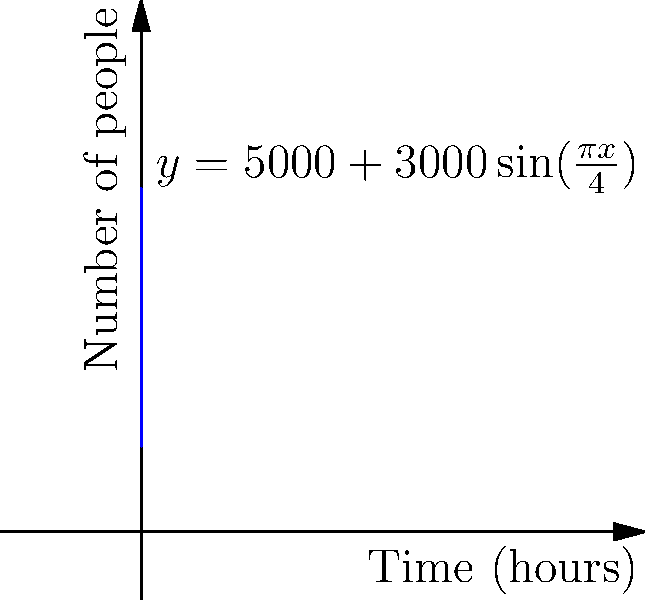As a hip-hop artist planning your debut concert, you want to understand crowd dynamics. The graph shows the number of people at a concert over time, represented by the function $y=5000+3000\sin(\frac{\pi x}{4})$, where $x$ is time in hours and $y$ is the number of people. Calculate the total person-hours spent at the concert during the 8-hour event. (Hint: Use a definite integral to find the area under the curve.) To solve this problem, we need to follow these steps:

1) The total person-hours is represented by the area under the curve from $x=0$ to $x=8$.

2) We can find this area using a definite integral:

   $$\int_0^8 [5000+3000\sin(\frac{\pi x}{4})] dx$$

3) Let's break this into two parts:
   
   $$\int_0^8 5000 dx + \int_0^8 3000\sin(\frac{\pi x}{4}) dx$$

4) For the first part:
   
   $$5000x|_0^8 = 5000(8) - 5000(0) = 40000$$

5) For the second part, we use the substitution $u = \frac{\pi x}{4}$:
   
   $$\frac{12000}{\pi/4} \int_0^{2\pi} \sin(u) du = \frac{48000}{\pi}[-\cos(u)]_0^{2\pi} = 0$$

6) Adding the results from steps 4 and 5:

   $$40000 + 0 = 40000$$

Therefore, the total person-hours spent at the concert is 40,000.
Answer: 40,000 person-hours 